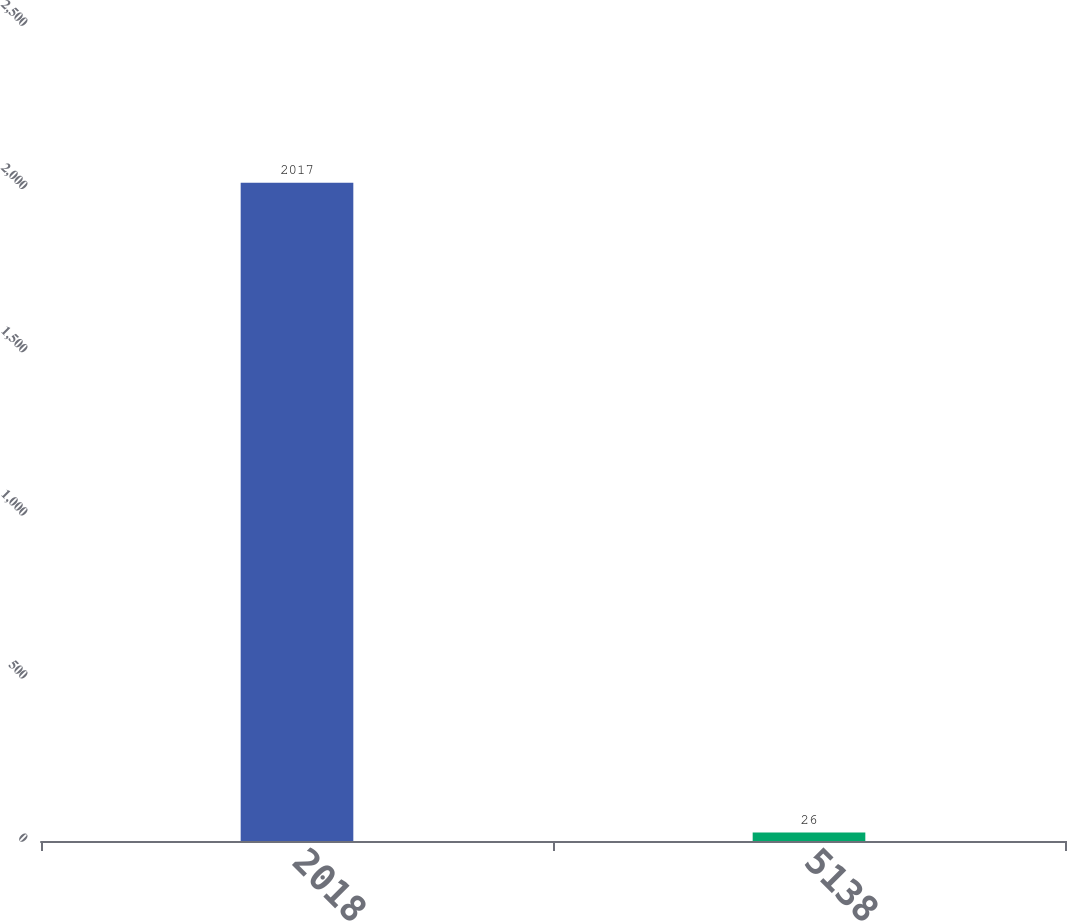<chart> <loc_0><loc_0><loc_500><loc_500><bar_chart><fcel>2018<fcel>5138<nl><fcel>2017<fcel>26<nl></chart> 